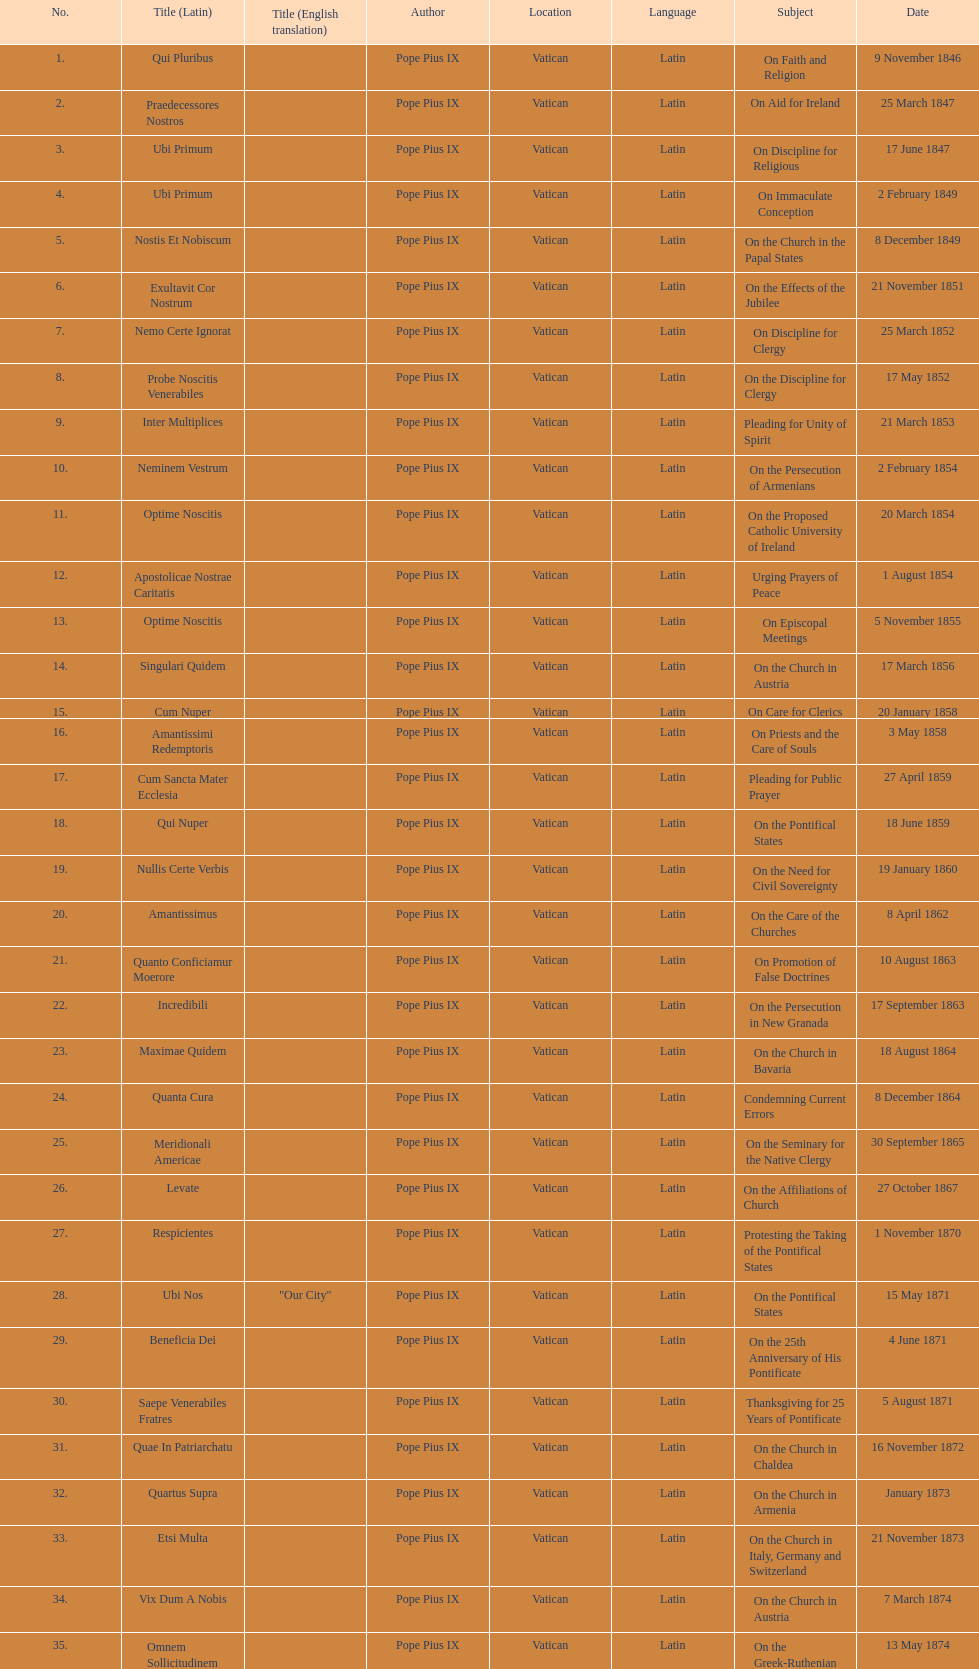What is the last title? Graves Ac Diuturnae. 